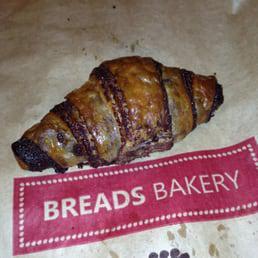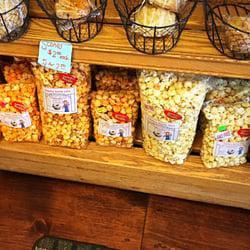The first image is the image on the left, the second image is the image on the right. Given the left and right images, does the statement "Loaves of bakery items are sitting in white rectangular containers in the image on the left." hold true? Answer yes or no. No. The first image is the image on the left, the second image is the image on the right. Considering the images on both sides, is "An image shows multiple baked treats of the same type, packaged in open-top white rectangular boxes." valid? Answer yes or no. No. 